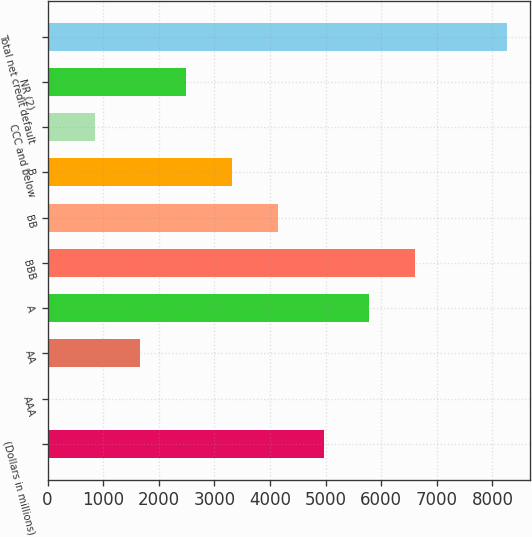Convert chart to OTSL. <chart><loc_0><loc_0><loc_500><loc_500><bar_chart><fcel>(Dollars in millions)<fcel>AAA<fcel>AA<fcel>A<fcel>BBB<fcel>BB<fcel>B<fcel>CCC and below<fcel>NR (2)<fcel>Total net credit default<nl><fcel>4965.2<fcel>23<fcel>1670.4<fcel>5788.9<fcel>6612.6<fcel>4141.5<fcel>3317.8<fcel>846.7<fcel>2494.1<fcel>8260<nl></chart> 